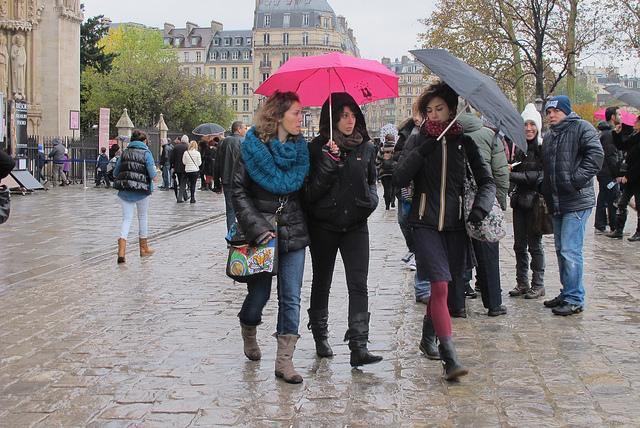How many colors are in the umbrella being held over the group's heads?
Short answer required. 1. How many umbrellas are there?
Write a very short answer. 4. What is around the girls neck?
Write a very short answer. Scarf. How many umbrellas are in the picture?
Write a very short answer. 5. What is the weather like?
Concise answer only. Rainy. 